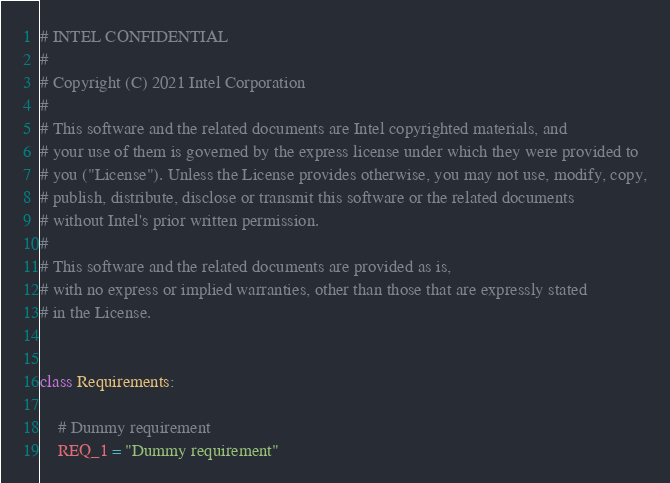Convert code to text. <code><loc_0><loc_0><loc_500><loc_500><_Python_># INTEL CONFIDENTIAL
#
# Copyright (C) 2021 Intel Corporation
#
# This software and the related documents are Intel copyrighted materials, and
# your use of them is governed by the express license under which they were provided to
# you ("License"). Unless the License provides otherwise, you may not use, modify, copy,
# publish, distribute, disclose or transmit this software or the related documents
# without Intel's prior written permission.
#
# This software and the related documents are provided as is,
# with no express or implied warranties, other than those that are expressly stated
# in the License.


class Requirements:

    # Dummy requirement
    REQ_1 = "Dummy requirement"
</code> 